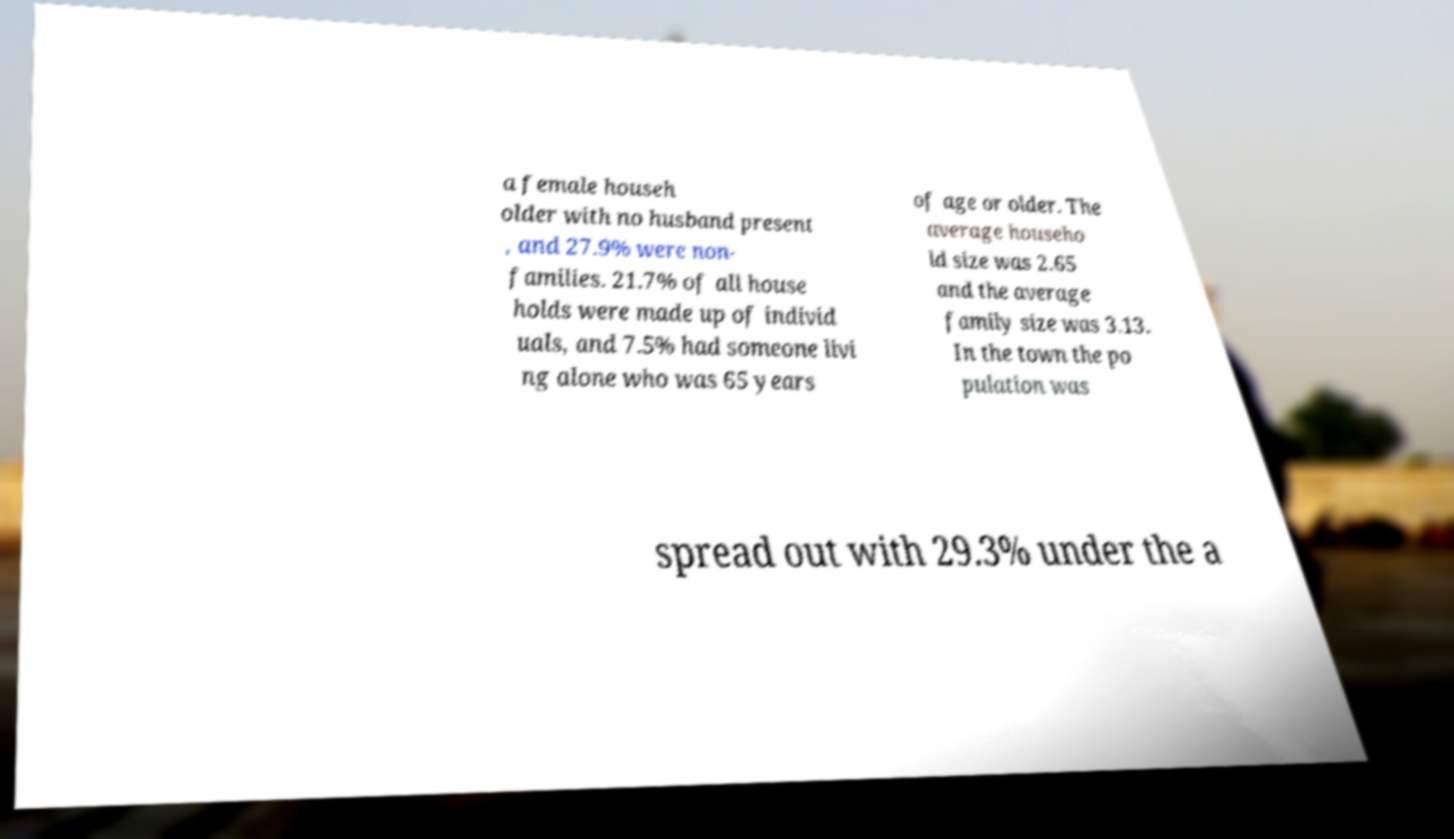I need the written content from this picture converted into text. Can you do that? a female househ older with no husband present , and 27.9% were non- families. 21.7% of all house holds were made up of individ uals, and 7.5% had someone livi ng alone who was 65 years of age or older. The average househo ld size was 2.65 and the average family size was 3.13. In the town the po pulation was spread out with 29.3% under the a 